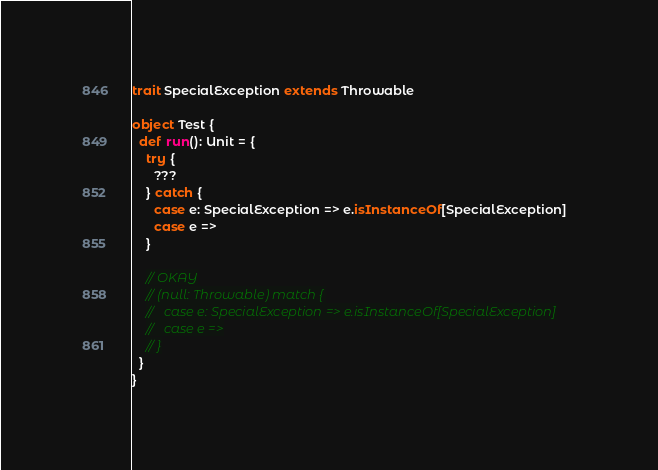<code> <loc_0><loc_0><loc_500><loc_500><_Scala_>trait SpecialException extends Throwable

object Test {
  def run(): Unit = {
    try {
      ???
    } catch {
      case e: SpecialException => e.isInstanceOf[SpecialException]
      case e =>
    }

    // OKAY
    // (null: Throwable) match {
    //   case e: SpecialException => e.isInstanceOf[SpecialException]
    //   case e =>
    // }
  }
}
</code> 